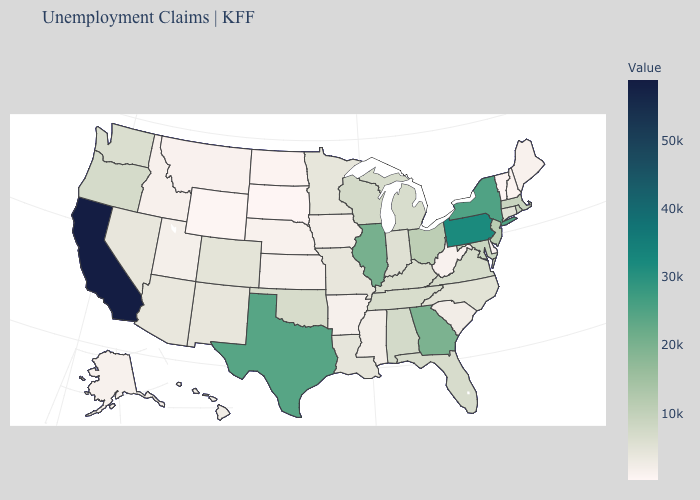Does South Dakota have the lowest value in the USA?
Answer briefly. Yes. Which states hav the highest value in the MidWest?
Quick response, please. Illinois. Does Nebraska have the lowest value in the MidWest?
Concise answer only. No. Among the states that border Arkansas , does Oklahoma have the lowest value?
Keep it brief. No. Among the states that border Arkansas , does Missouri have the highest value?
Give a very brief answer. No. 